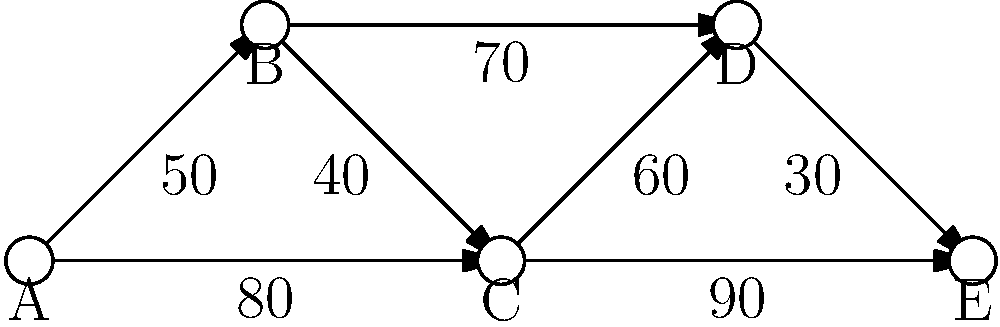As a Scamp owner planning a road trip through Sweden, you want to find the shortest route between campgrounds. The network diagram shows five campgrounds (A to E) with distances in kilometers between them. What is the shortest distance from campground A to campground E? To find the shortest distance from A to E, we'll use Dijkstra's algorithm:

1. Initialize:
   - Distance to A: 0
   - Distance to all other nodes: infinity
   - Unvisited nodes: A, B, C, D, E

2. From A:
   - A to B: 50 km
   - A to C: 80 km
   - Mark A as visited

3. From B (current shortest path):
   - B to C: 50 + 40 = 90 km (longer than direct A to C)
   - B to D: 50 + 70 = 120 km
   - Mark B as visited

4. From C:
   - C to D: 80 + 60 = 140 km (longer than B to D)
   - C to E: 80 + 90 = 170 km
   - Mark C as visited

5. From D:
   - D to E: 120 + 30 = 150 km
   - Mark D as visited

6. E is the only unvisited node left, so we're done.

The shortest path is A -> B -> D -> E, with a total distance of 150 km.
Answer: 150 km 